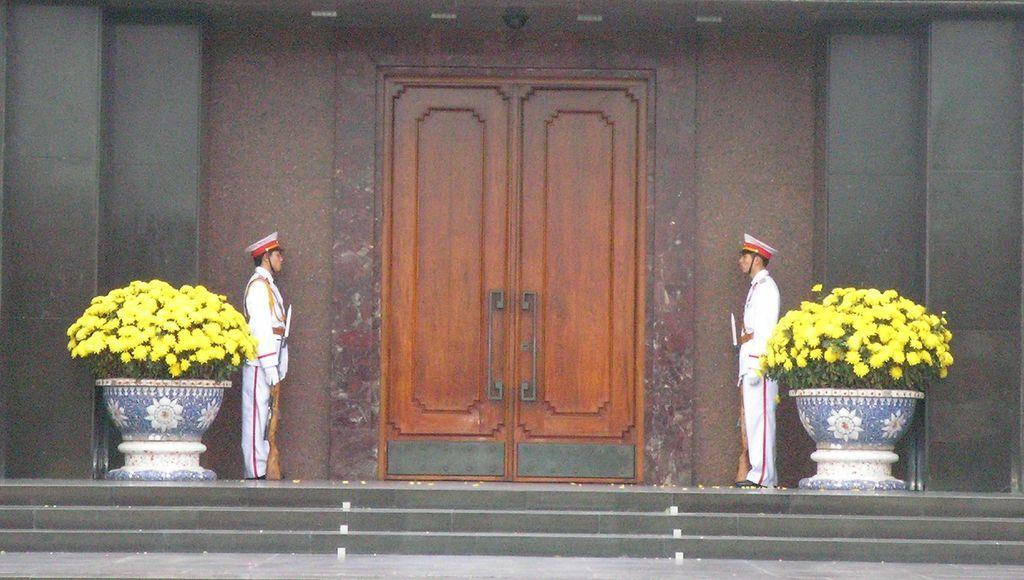Describe this image in one or two sentences. At the bottom of the image there are steps. On the floor there are two men with white dresses, caps on their heads and guns in their hands are standing. Behind them there are two flower pots with plants and yellow flowers. Behind those men there is a wall with door and also there are black colored pillars. 